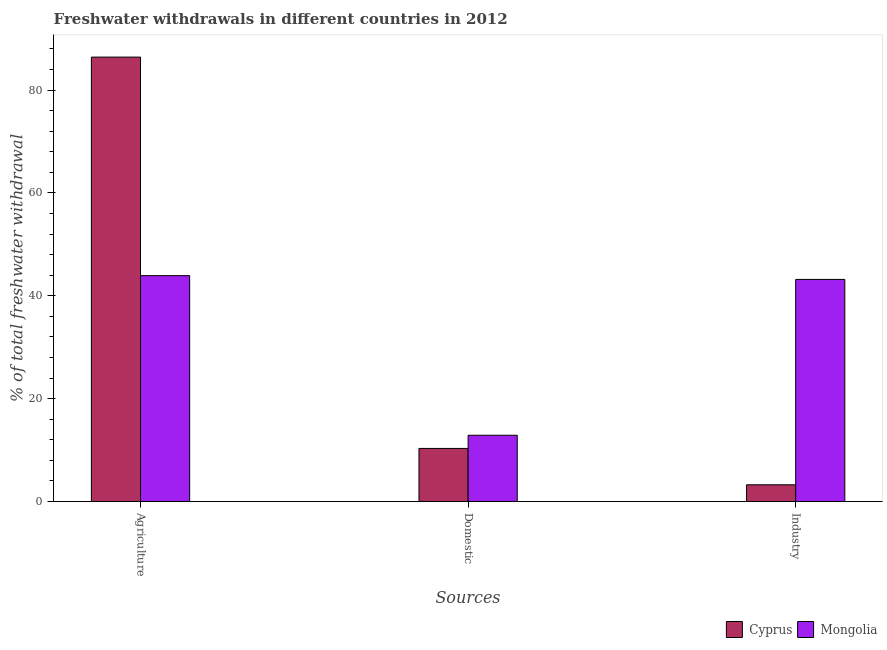How many different coloured bars are there?
Provide a short and direct response. 2. Are the number of bars on each tick of the X-axis equal?
Your response must be concise. Yes. How many bars are there on the 2nd tick from the left?
Your answer should be very brief. 2. How many bars are there on the 1st tick from the right?
Your response must be concise. 2. What is the label of the 1st group of bars from the left?
Your answer should be very brief. Agriculture. What is the percentage of freshwater withdrawal for agriculture in Mongolia?
Provide a succinct answer. 43.92. Across all countries, what is the maximum percentage of freshwater withdrawal for domestic purposes?
Your response must be concise. 12.89. Across all countries, what is the minimum percentage of freshwater withdrawal for agriculture?
Ensure brevity in your answer.  43.92. In which country was the percentage of freshwater withdrawal for domestic purposes maximum?
Your answer should be compact. Mongolia. In which country was the percentage of freshwater withdrawal for domestic purposes minimum?
Provide a short and direct response. Cyprus. What is the total percentage of freshwater withdrawal for agriculture in the graph?
Provide a short and direct response. 130.33. What is the difference between the percentage of freshwater withdrawal for agriculture in Mongolia and that in Cyprus?
Your answer should be very brief. -42.49. What is the difference between the percentage of freshwater withdrawal for industry in Cyprus and the percentage of freshwater withdrawal for agriculture in Mongolia?
Make the answer very short. -40.66. What is the average percentage of freshwater withdrawal for agriculture per country?
Your response must be concise. 65.16. What is the difference between the percentage of freshwater withdrawal for industry and percentage of freshwater withdrawal for domestic purposes in Cyprus?
Offer a terse response. -7.07. What is the ratio of the percentage of freshwater withdrawal for industry in Mongolia to that in Cyprus?
Keep it short and to the point. 13.24. Is the percentage of freshwater withdrawal for industry in Mongolia less than that in Cyprus?
Ensure brevity in your answer.  No. Is the difference between the percentage of freshwater withdrawal for industry in Cyprus and Mongolia greater than the difference between the percentage of freshwater withdrawal for domestic purposes in Cyprus and Mongolia?
Your answer should be compact. No. What is the difference between the highest and the second highest percentage of freshwater withdrawal for industry?
Offer a terse response. 39.93. What is the difference between the highest and the lowest percentage of freshwater withdrawal for domestic purposes?
Make the answer very short. 2.56. Is the sum of the percentage of freshwater withdrawal for industry in Cyprus and Mongolia greater than the maximum percentage of freshwater withdrawal for agriculture across all countries?
Offer a very short reply. No. What does the 1st bar from the left in Agriculture represents?
Your response must be concise. Cyprus. What does the 1st bar from the right in Industry represents?
Your answer should be compact. Mongolia. How many bars are there?
Make the answer very short. 6. How many countries are there in the graph?
Provide a short and direct response. 2. Does the graph contain any zero values?
Provide a succinct answer. No. Where does the legend appear in the graph?
Ensure brevity in your answer.  Bottom right. How are the legend labels stacked?
Your answer should be compact. Horizontal. What is the title of the graph?
Make the answer very short. Freshwater withdrawals in different countries in 2012. Does "Small states" appear as one of the legend labels in the graph?
Offer a very short reply. No. What is the label or title of the X-axis?
Your answer should be very brief. Sources. What is the label or title of the Y-axis?
Provide a short and direct response. % of total freshwater withdrawal. What is the % of total freshwater withdrawal in Cyprus in Agriculture?
Offer a terse response. 86.41. What is the % of total freshwater withdrawal of Mongolia in Agriculture?
Provide a succinct answer. 43.92. What is the % of total freshwater withdrawal of Cyprus in Domestic?
Provide a succinct answer. 10.33. What is the % of total freshwater withdrawal in Mongolia in Domestic?
Give a very brief answer. 12.89. What is the % of total freshwater withdrawal of Cyprus in Industry?
Ensure brevity in your answer.  3.26. What is the % of total freshwater withdrawal in Mongolia in Industry?
Make the answer very short. 43.19. Across all Sources, what is the maximum % of total freshwater withdrawal in Cyprus?
Your response must be concise. 86.41. Across all Sources, what is the maximum % of total freshwater withdrawal in Mongolia?
Your answer should be compact. 43.92. Across all Sources, what is the minimum % of total freshwater withdrawal in Cyprus?
Ensure brevity in your answer.  3.26. Across all Sources, what is the minimum % of total freshwater withdrawal in Mongolia?
Offer a terse response. 12.89. What is the total % of total freshwater withdrawal in Cyprus in the graph?
Keep it short and to the point. 100. What is the total % of total freshwater withdrawal of Mongolia in the graph?
Keep it short and to the point. 100. What is the difference between the % of total freshwater withdrawal of Cyprus in Agriculture and that in Domestic?
Offer a terse response. 76.08. What is the difference between the % of total freshwater withdrawal in Mongolia in Agriculture and that in Domestic?
Give a very brief answer. 31.03. What is the difference between the % of total freshwater withdrawal in Cyprus in Agriculture and that in Industry?
Ensure brevity in your answer.  83.15. What is the difference between the % of total freshwater withdrawal of Mongolia in Agriculture and that in Industry?
Offer a very short reply. 0.73. What is the difference between the % of total freshwater withdrawal of Cyprus in Domestic and that in Industry?
Ensure brevity in your answer.  7.07. What is the difference between the % of total freshwater withdrawal of Mongolia in Domestic and that in Industry?
Your answer should be compact. -30.3. What is the difference between the % of total freshwater withdrawal of Cyprus in Agriculture and the % of total freshwater withdrawal of Mongolia in Domestic?
Provide a short and direct response. 73.52. What is the difference between the % of total freshwater withdrawal of Cyprus in Agriculture and the % of total freshwater withdrawal of Mongolia in Industry?
Provide a succinct answer. 43.22. What is the difference between the % of total freshwater withdrawal in Cyprus in Domestic and the % of total freshwater withdrawal in Mongolia in Industry?
Offer a terse response. -32.86. What is the average % of total freshwater withdrawal of Cyprus per Sources?
Your response must be concise. 33.33. What is the average % of total freshwater withdrawal of Mongolia per Sources?
Ensure brevity in your answer.  33.33. What is the difference between the % of total freshwater withdrawal of Cyprus and % of total freshwater withdrawal of Mongolia in Agriculture?
Give a very brief answer. 42.49. What is the difference between the % of total freshwater withdrawal of Cyprus and % of total freshwater withdrawal of Mongolia in Domestic?
Offer a very short reply. -2.56. What is the difference between the % of total freshwater withdrawal in Cyprus and % of total freshwater withdrawal in Mongolia in Industry?
Offer a terse response. -39.93. What is the ratio of the % of total freshwater withdrawal in Cyprus in Agriculture to that in Domestic?
Offer a very short reply. 8.37. What is the ratio of the % of total freshwater withdrawal of Mongolia in Agriculture to that in Domestic?
Provide a succinct answer. 3.41. What is the ratio of the % of total freshwater withdrawal of Cyprus in Agriculture to that in Industry?
Offer a very short reply. 26.5. What is the ratio of the % of total freshwater withdrawal of Mongolia in Agriculture to that in Industry?
Ensure brevity in your answer.  1.02. What is the ratio of the % of total freshwater withdrawal in Cyprus in Domestic to that in Industry?
Give a very brief answer. 3.17. What is the ratio of the % of total freshwater withdrawal in Mongolia in Domestic to that in Industry?
Provide a succinct answer. 0.3. What is the difference between the highest and the second highest % of total freshwater withdrawal of Cyprus?
Offer a very short reply. 76.08. What is the difference between the highest and the second highest % of total freshwater withdrawal in Mongolia?
Your answer should be very brief. 0.73. What is the difference between the highest and the lowest % of total freshwater withdrawal in Cyprus?
Make the answer very short. 83.15. What is the difference between the highest and the lowest % of total freshwater withdrawal of Mongolia?
Make the answer very short. 31.03. 